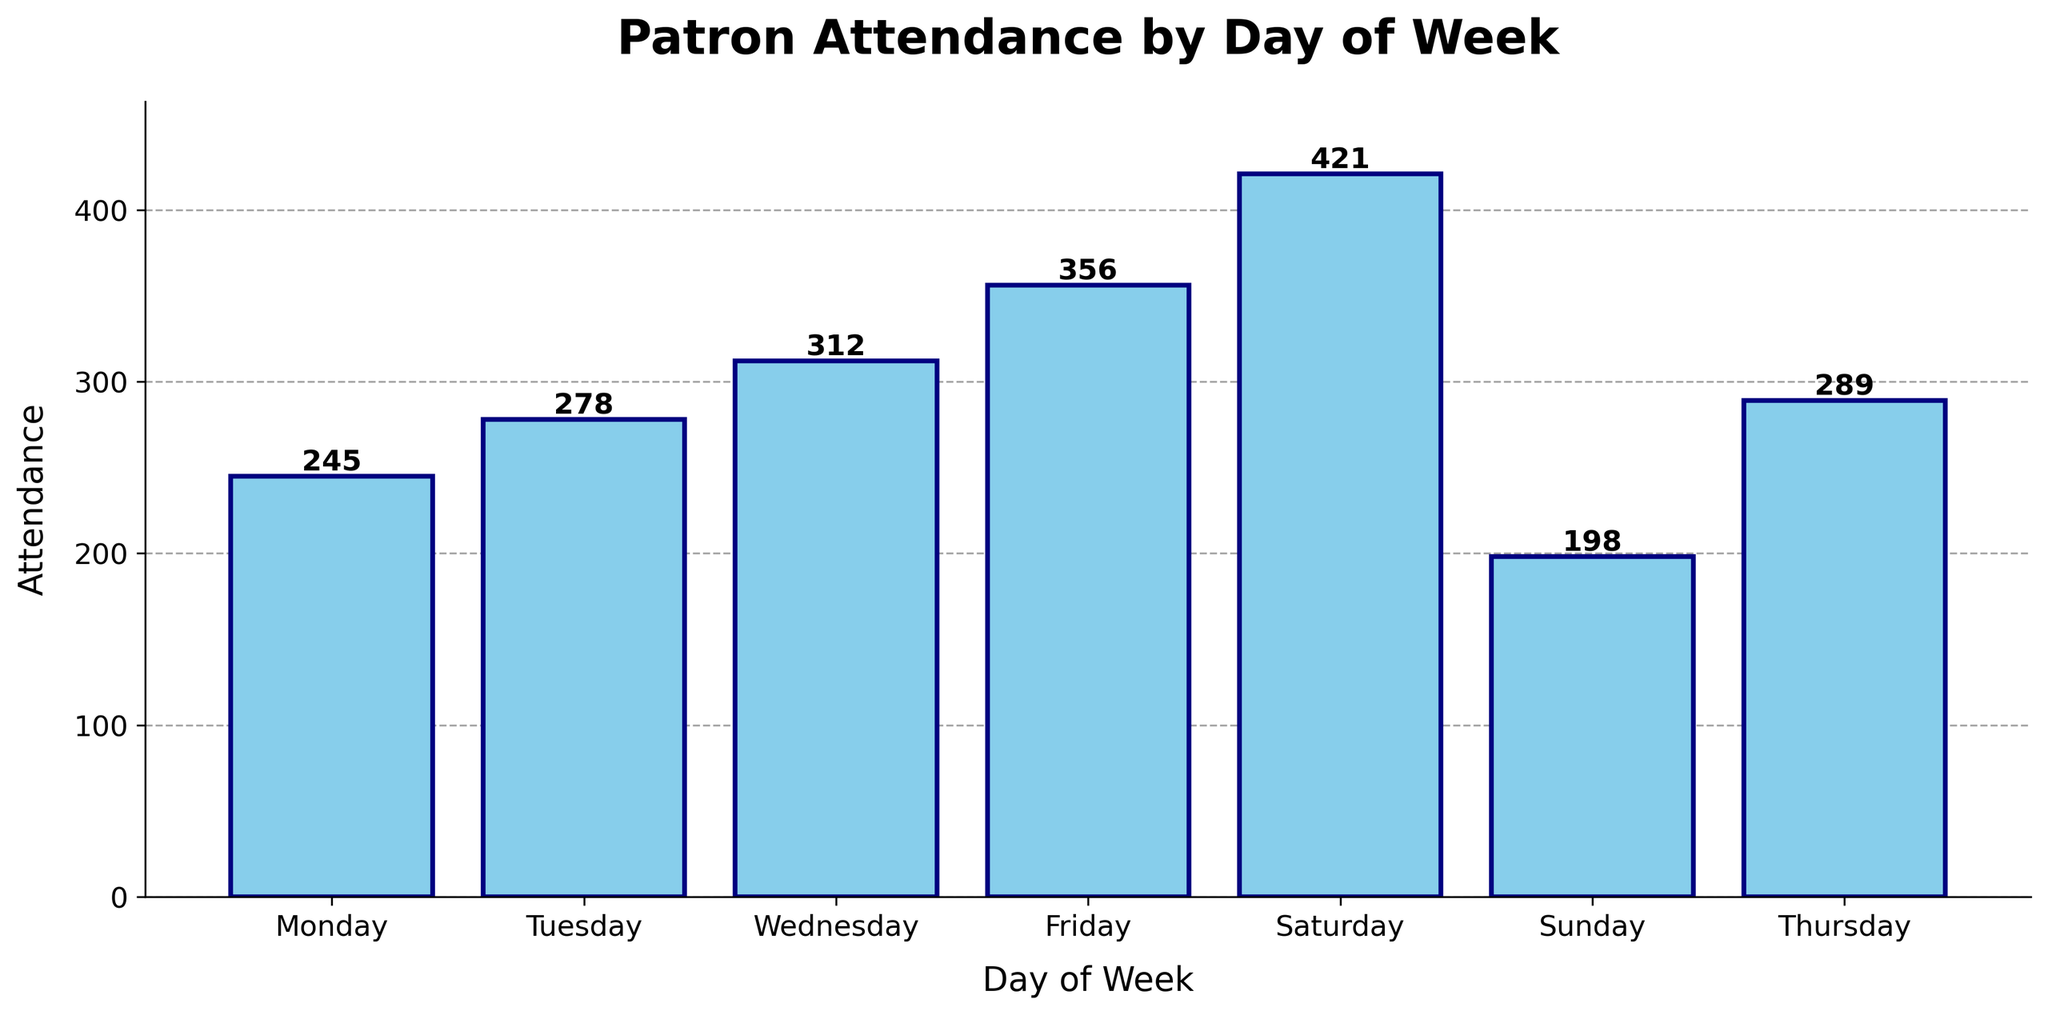What is the day with the highest patron attendance? Look at the heights of the bars for each day. The bar for Saturday is the tallest, indicating the highest attendance at 421.
Answer: Saturday Which day has the lowest patron attendance? Observe the heights of the bars across all days. The bar for Sunday is the shortest, indicating the lowest attendance at 198.
Answer: Sunday What is the total patron attendance for Monday, Tuesday, and Wednesday? Add the attendance values for Monday, Tuesday, and Wednesday: 245 + 278 + 312 = 835.
Answer: 835 How much more is the attendance on Friday compared to Monday? Subtract the attendance of Monday from Friday: 356 - 245 = 111.
Answer: 111 What is the average patron attendance over the week? Sum the attendance values for all days and divide by the number of days: (245 + 278 + 312 + 356 + 421 + 198 + 289) / 7 = 2,099 / 7 ≈ 300.
Answer: 300 Is the attendance on Thursday greater than the attendance on Tuesday? Compare the attendance values: Thursday (289) is greater than Tuesday (278).
Answer: Yes Which days have an attendance greater than 300? Identify the days with attendance values greater than 300 (Wednesday, Friday, and Saturday).
Answer: Wednesday, Friday, Saturday What is the difference in attendance between the day with the highest attendance and the day with the lowest attendance? Subtract the attendance of Sunday (lowest) from Saturday (highest): 421 - 198 = 223.
Answer: 223 On which day does the attendance exceed 400? Check the attendance values for each day. Only Saturday exceeds 400 with 421.
Answer: Saturday How does the attendance on Sunday compare to the average weekly attendance? The average weekly attendance is approximately 300. Sunday has 198, which is less than the average.
Answer: Less than average 